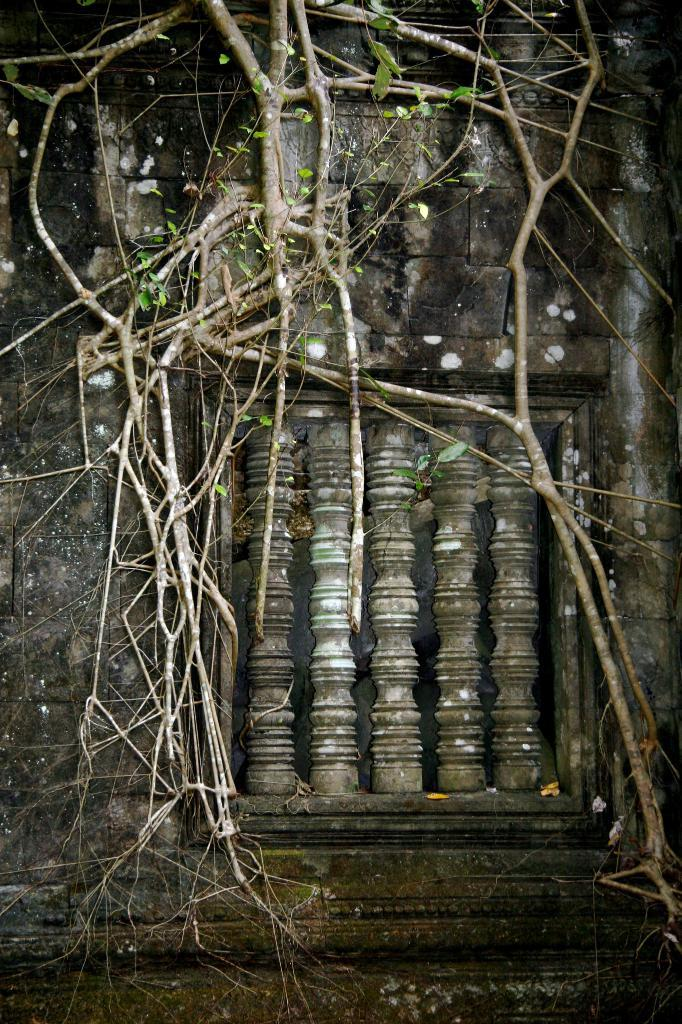What is the main structure in the image? There is a wall in the image. What can be seen on the wall? Tree branches and leaves are present on the wall. Is there any opening or feature in the middle of the wall? Yes, there is an object in the middle of the wall that resembles a window. What type of bait is being used by the birds on the wall in the image? There are no birds or bait present in the image. Can you see a skateboarder performing tricks on the wall in the image? There is no skateboarder or any indication of a skateboarding activity in the image. 